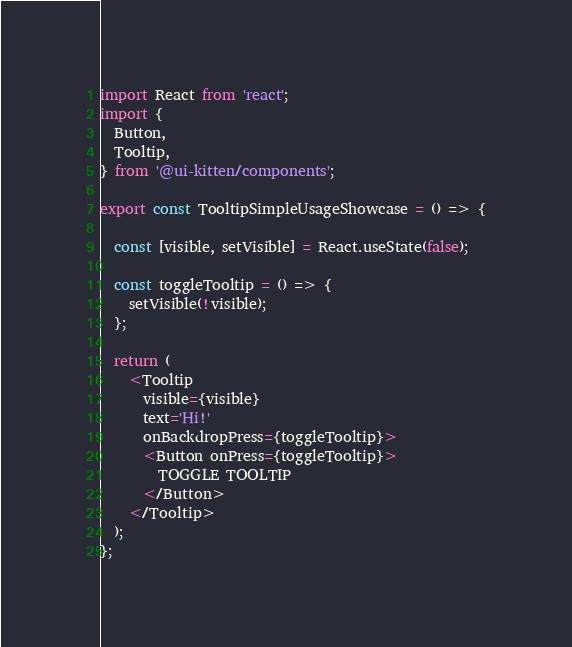<code> <loc_0><loc_0><loc_500><loc_500><_TypeScript_>import React from 'react';
import {
  Button,
  Tooltip,
} from '@ui-kitten/components';

export const TooltipSimpleUsageShowcase = () => {

  const [visible, setVisible] = React.useState(false);

  const toggleTooltip = () => {
    setVisible(!visible);
  };

  return (
    <Tooltip
      visible={visible}
      text='Hi!'
      onBackdropPress={toggleTooltip}>
      <Button onPress={toggleTooltip}>
        TOGGLE TOOLTIP
      </Button>
    </Tooltip>
  );
};
</code> 